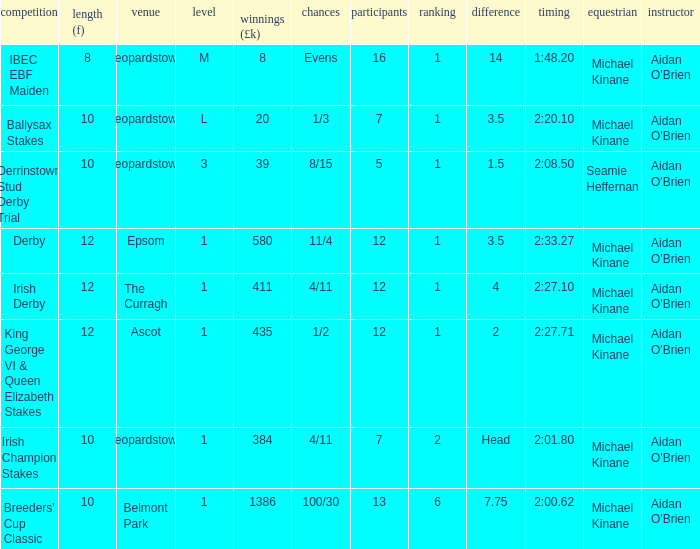Which Dist (f) has a Race of irish derby? 12.0. 